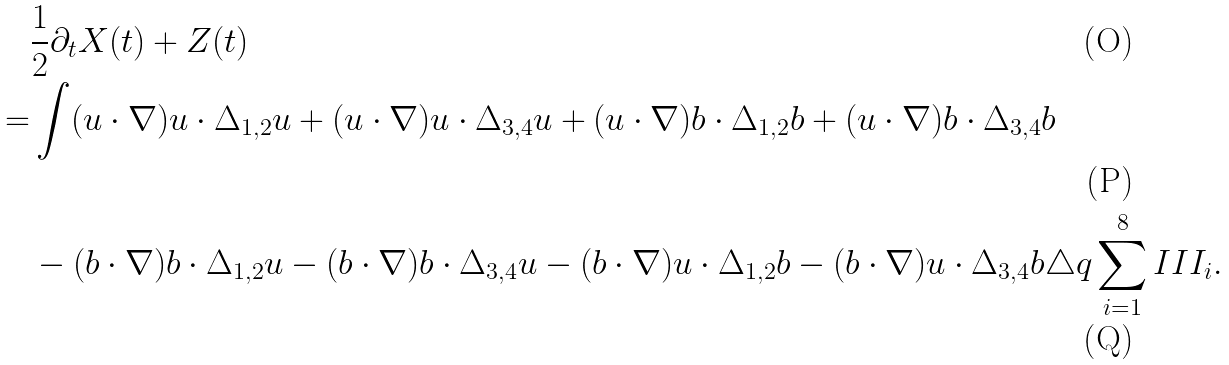Convert formula to latex. <formula><loc_0><loc_0><loc_500><loc_500>& \frac { 1 } { 2 } \partial _ { t } X ( t ) + Z ( t ) \\ = & \int ( u \cdot \nabla ) u \cdot \Delta _ { 1 , 2 } u + ( u \cdot \nabla ) u \cdot \Delta _ { 3 , 4 } u + ( u \cdot \nabla ) b \cdot \Delta _ { 1 , 2 } b + ( u \cdot \nabla ) b \cdot \Delta _ { 3 , 4 } b \\ & - ( b \cdot \nabla ) b \cdot \Delta _ { 1 , 2 } u - ( b \cdot \nabla ) b \cdot \Delta _ { 3 , 4 } u - ( b \cdot \nabla ) u \cdot \Delta _ { 1 , 2 } b - ( b \cdot \nabla ) u \cdot \Delta _ { 3 , 4 } b \triangle q \sum _ { i = 1 } ^ { 8 } I I I _ { i } .</formula> 